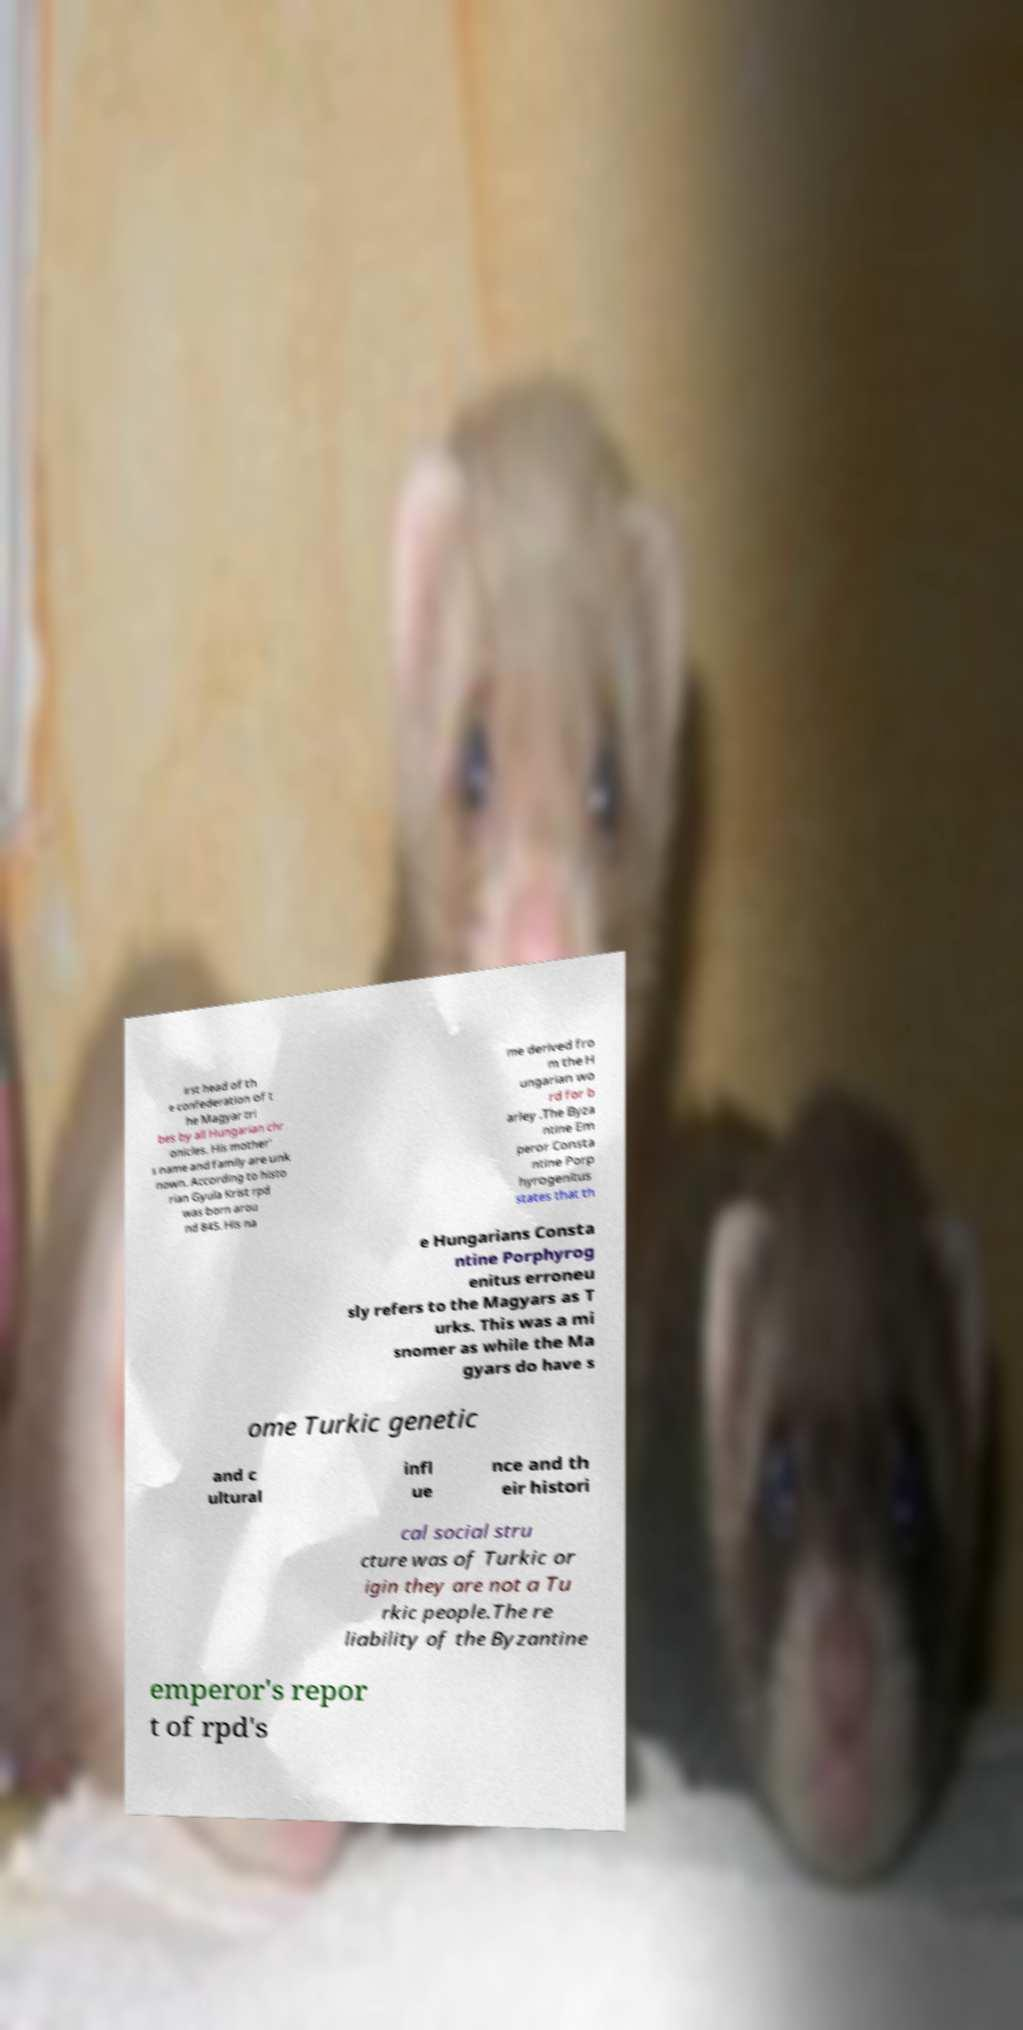Could you extract and type out the text from this image? irst head of th e confederation of t he Magyar tri bes by all Hungarian chr onicles. His mother' s name and family are unk nown. According to histo rian Gyula Krist rpd was born arou nd 845. His na me derived fro m the H ungarian wo rd for b arley .The Byza ntine Em peror Consta ntine Porp hyrogenitus states that th e Hungarians Consta ntine Porphyrog enitus erroneu sly refers to the Magyars as T urks. This was a mi snomer as while the Ma gyars do have s ome Turkic genetic and c ultural infl ue nce and th eir histori cal social stru cture was of Turkic or igin they are not a Tu rkic people.The re liability of the Byzantine emperor's repor t of rpd's 